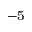Convert formula to latex. <formula><loc_0><loc_0><loc_500><loc_500>^ { - 5 }</formula> 